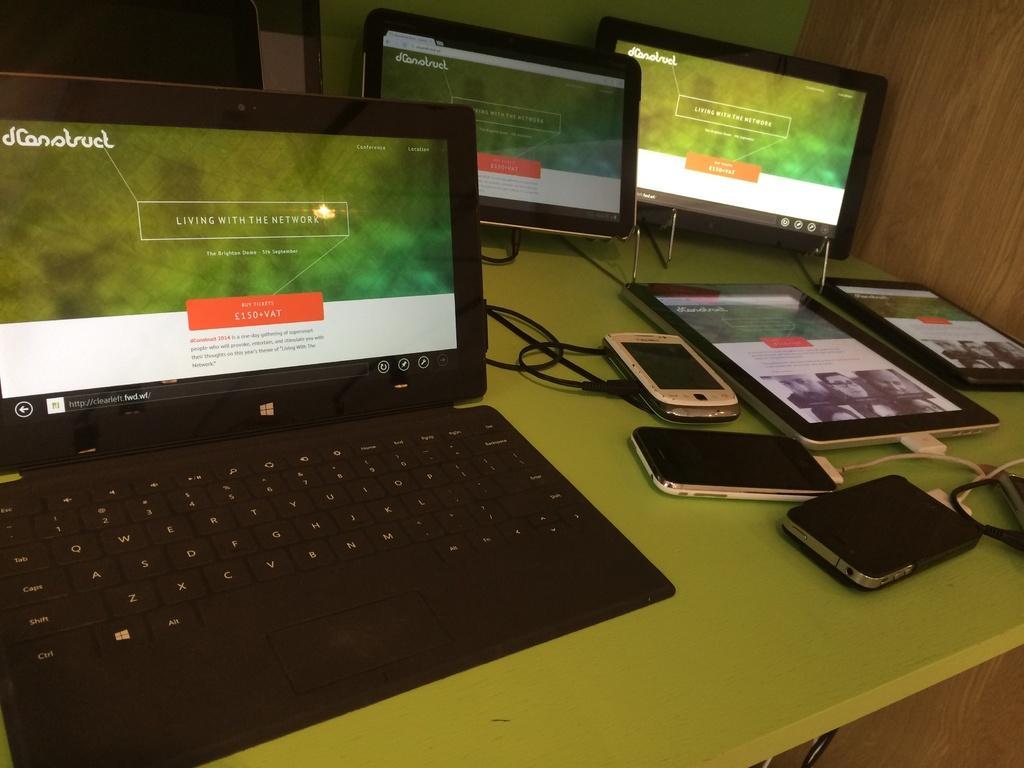Describe this image in one or two sentences. In the picture there is a table and on the table there are laptops and mobile phones and other gadgets. 